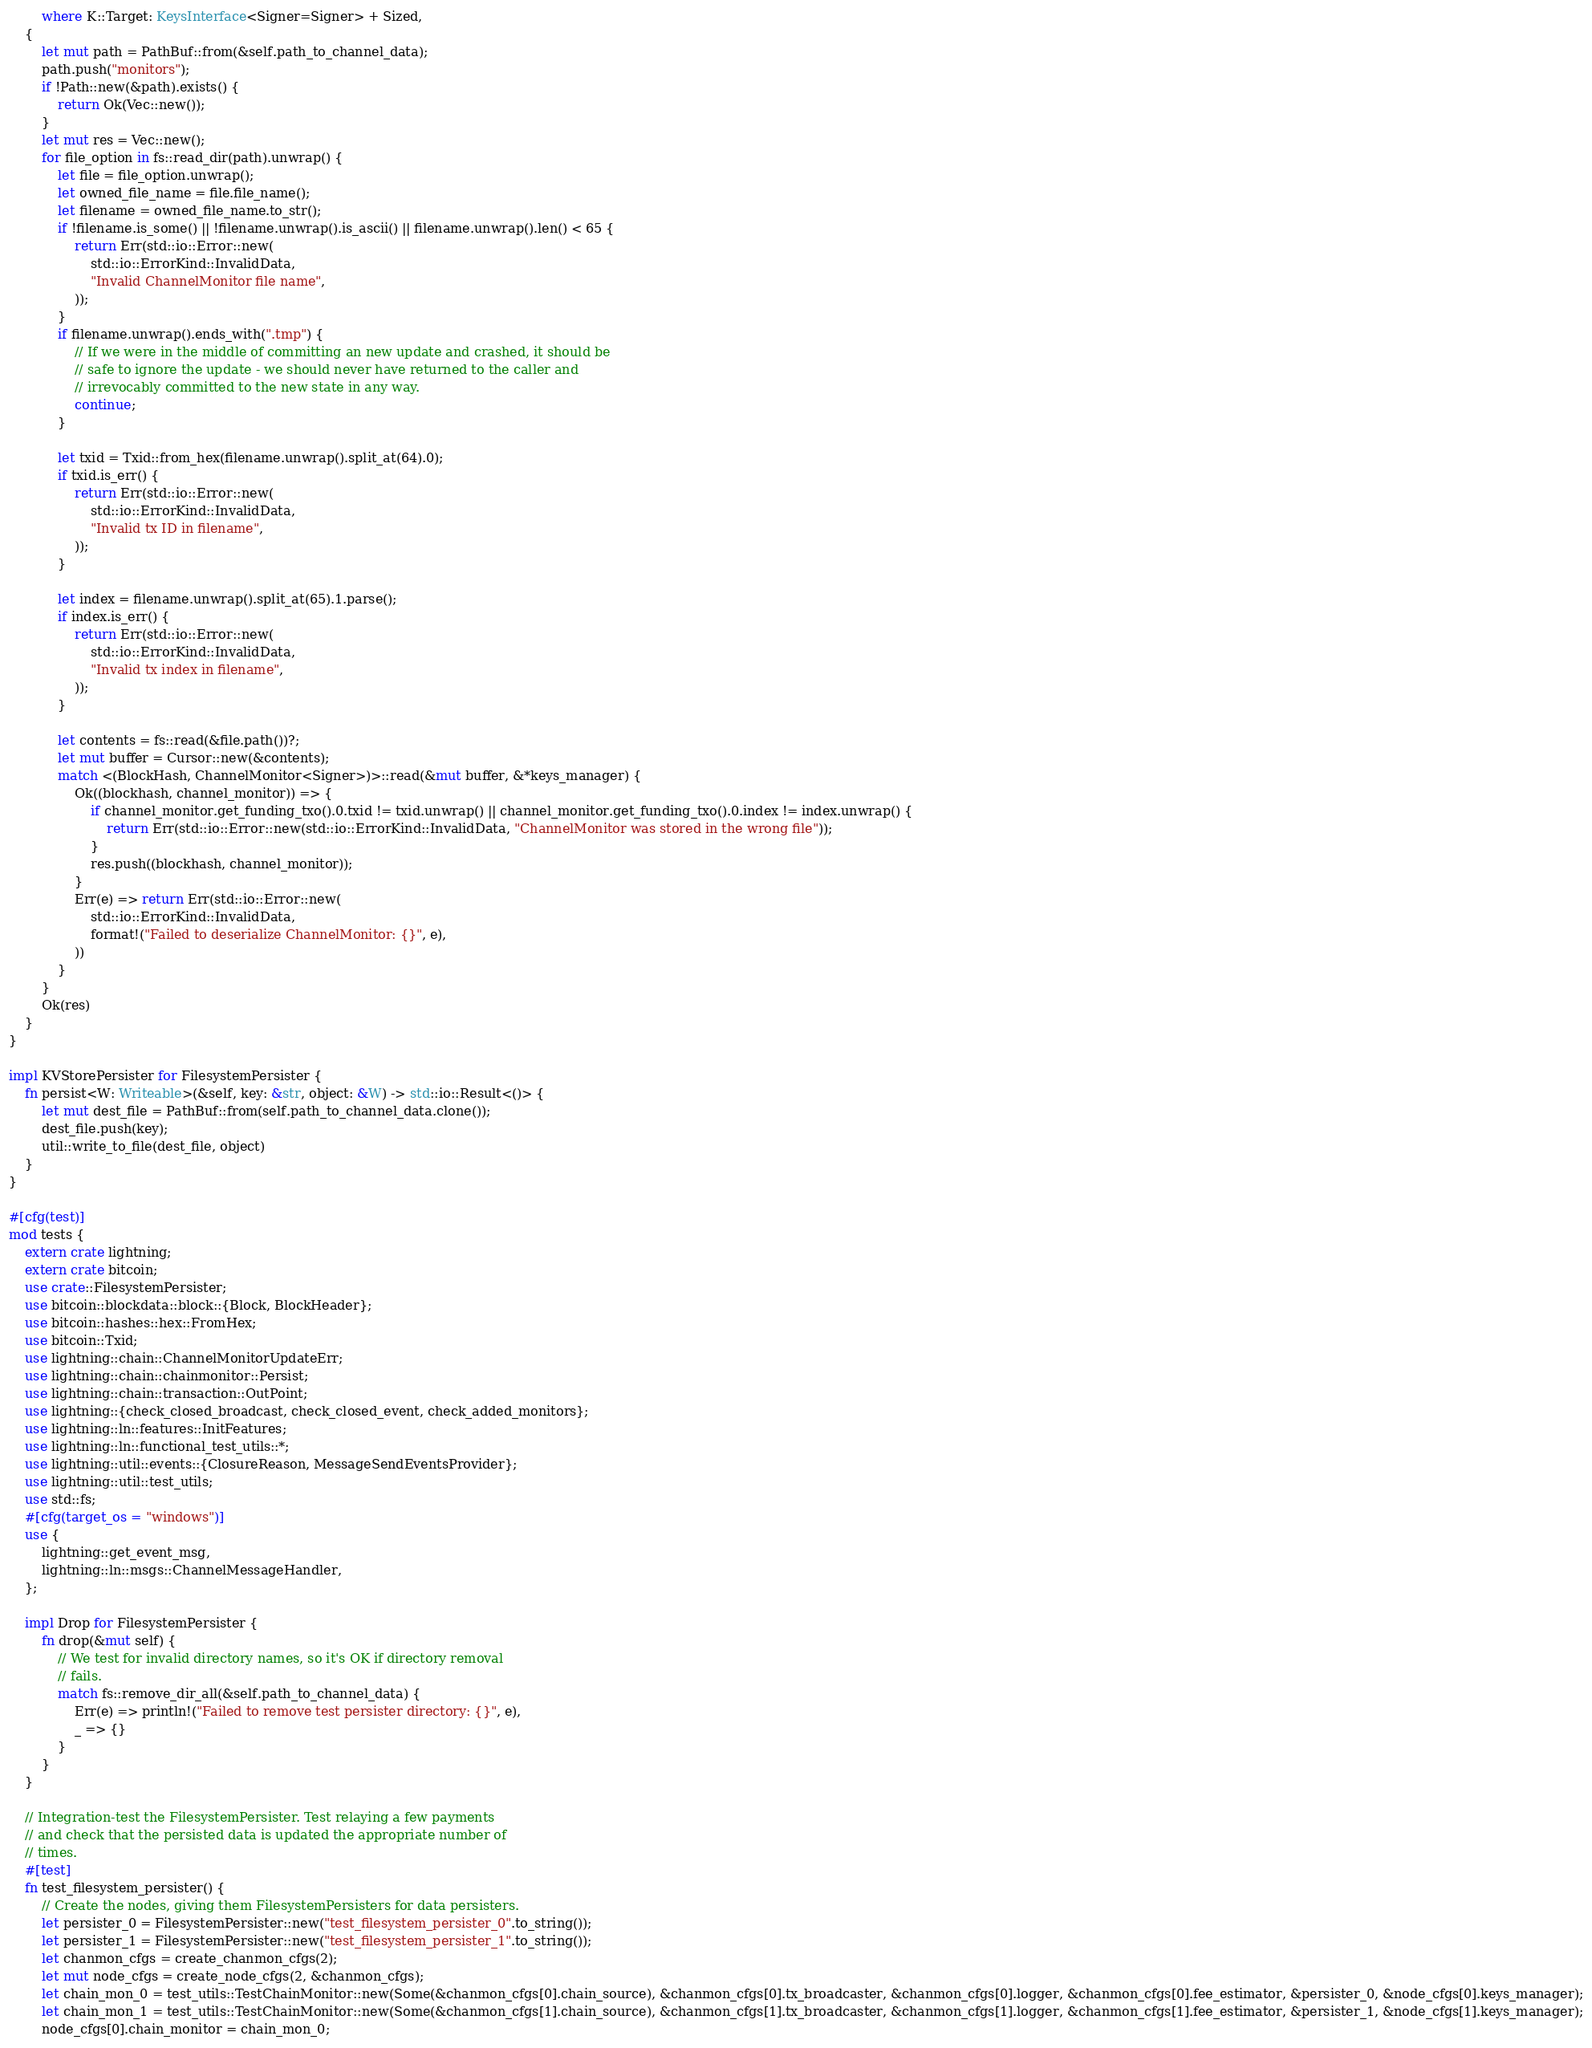<code> <loc_0><loc_0><loc_500><loc_500><_Rust_>		where K::Target: KeysInterface<Signer=Signer> + Sized,
	{
		let mut path = PathBuf::from(&self.path_to_channel_data);
		path.push("monitors");
		if !Path::new(&path).exists() {
			return Ok(Vec::new());
		}
		let mut res = Vec::new();
		for file_option in fs::read_dir(path).unwrap() {
			let file = file_option.unwrap();
			let owned_file_name = file.file_name();
			let filename = owned_file_name.to_str();
			if !filename.is_some() || !filename.unwrap().is_ascii() || filename.unwrap().len() < 65 {
				return Err(std::io::Error::new(
					std::io::ErrorKind::InvalidData,
					"Invalid ChannelMonitor file name",
				));
			}
			if filename.unwrap().ends_with(".tmp") {
				// If we were in the middle of committing an new update and crashed, it should be
				// safe to ignore the update - we should never have returned to the caller and
				// irrevocably committed to the new state in any way.
				continue;
			}

			let txid = Txid::from_hex(filename.unwrap().split_at(64).0);
			if txid.is_err() {
				return Err(std::io::Error::new(
					std::io::ErrorKind::InvalidData,
					"Invalid tx ID in filename",
				));
			}

			let index = filename.unwrap().split_at(65).1.parse();
			if index.is_err() {
				return Err(std::io::Error::new(
					std::io::ErrorKind::InvalidData,
					"Invalid tx index in filename",
				));
			}

			let contents = fs::read(&file.path())?;
			let mut buffer = Cursor::new(&contents);
			match <(BlockHash, ChannelMonitor<Signer>)>::read(&mut buffer, &*keys_manager) {
				Ok((blockhash, channel_monitor)) => {
					if channel_monitor.get_funding_txo().0.txid != txid.unwrap() || channel_monitor.get_funding_txo().0.index != index.unwrap() {
						return Err(std::io::Error::new(std::io::ErrorKind::InvalidData, "ChannelMonitor was stored in the wrong file"));
					}
					res.push((blockhash, channel_monitor));
				}
				Err(e) => return Err(std::io::Error::new(
					std::io::ErrorKind::InvalidData,
					format!("Failed to deserialize ChannelMonitor: {}", e),
				))
			}
		}
		Ok(res)
	}
}

impl KVStorePersister for FilesystemPersister {
	fn persist<W: Writeable>(&self, key: &str, object: &W) -> std::io::Result<()> {
		let mut dest_file = PathBuf::from(self.path_to_channel_data.clone());
		dest_file.push(key);
		util::write_to_file(dest_file, object)
	}
}

#[cfg(test)]
mod tests {
	extern crate lightning;
	extern crate bitcoin;
	use crate::FilesystemPersister;
	use bitcoin::blockdata::block::{Block, BlockHeader};
	use bitcoin::hashes::hex::FromHex;
	use bitcoin::Txid;
	use lightning::chain::ChannelMonitorUpdateErr;
	use lightning::chain::chainmonitor::Persist;
	use lightning::chain::transaction::OutPoint;
	use lightning::{check_closed_broadcast, check_closed_event, check_added_monitors};
	use lightning::ln::features::InitFeatures;
	use lightning::ln::functional_test_utils::*;
	use lightning::util::events::{ClosureReason, MessageSendEventsProvider};
	use lightning::util::test_utils;
	use std::fs;
	#[cfg(target_os = "windows")]
	use {
		lightning::get_event_msg,
		lightning::ln::msgs::ChannelMessageHandler,
	};

	impl Drop for FilesystemPersister {
		fn drop(&mut self) {
			// We test for invalid directory names, so it's OK if directory removal
			// fails.
			match fs::remove_dir_all(&self.path_to_channel_data) {
				Err(e) => println!("Failed to remove test persister directory: {}", e),
				_ => {}
			}
		}
	}

	// Integration-test the FilesystemPersister. Test relaying a few payments
	// and check that the persisted data is updated the appropriate number of
	// times.
	#[test]
	fn test_filesystem_persister() {
		// Create the nodes, giving them FilesystemPersisters for data persisters.
		let persister_0 = FilesystemPersister::new("test_filesystem_persister_0".to_string());
		let persister_1 = FilesystemPersister::new("test_filesystem_persister_1".to_string());
		let chanmon_cfgs = create_chanmon_cfgs(2);
		let mut node_cfgs = create_node_cfgs(2, &chanmon_cfgs);
		let chain_mon_0 = test_utils::TestChainMonitor::new(Some(&chanmon_cfgs[0].chain_source), &chanmon_cfgs[0].tx_broadcaster, &chanmon_cfgs[0].logger, &chanmon_cfgs[0].fee_estimator, &persister_0, &node_cfgs[0].keys_manager);
		let chain_mon_1 = test_utils::TestChainMonitor::new(Some(&chanmon_cfgs[1].chain_source), &chanmon_cfgs[1].tx_broadcaster, &chanmon_cfgs[1].logger, &chanmon_cfgs[1].fee_estimator, &persister_1, &node_cfgs[1].keys_manager);
		node_cfgs[0].chain_monitor = chain_mon_0;</code> 